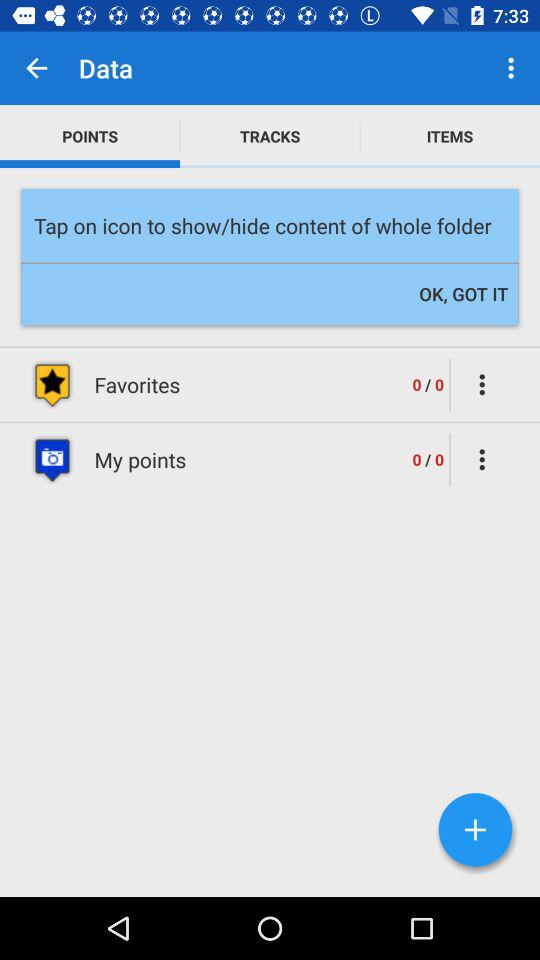What is the total number of points for "Favorites"? The total number of points is 0. 